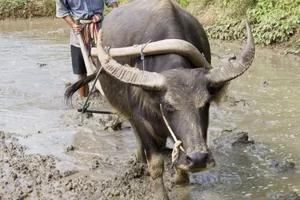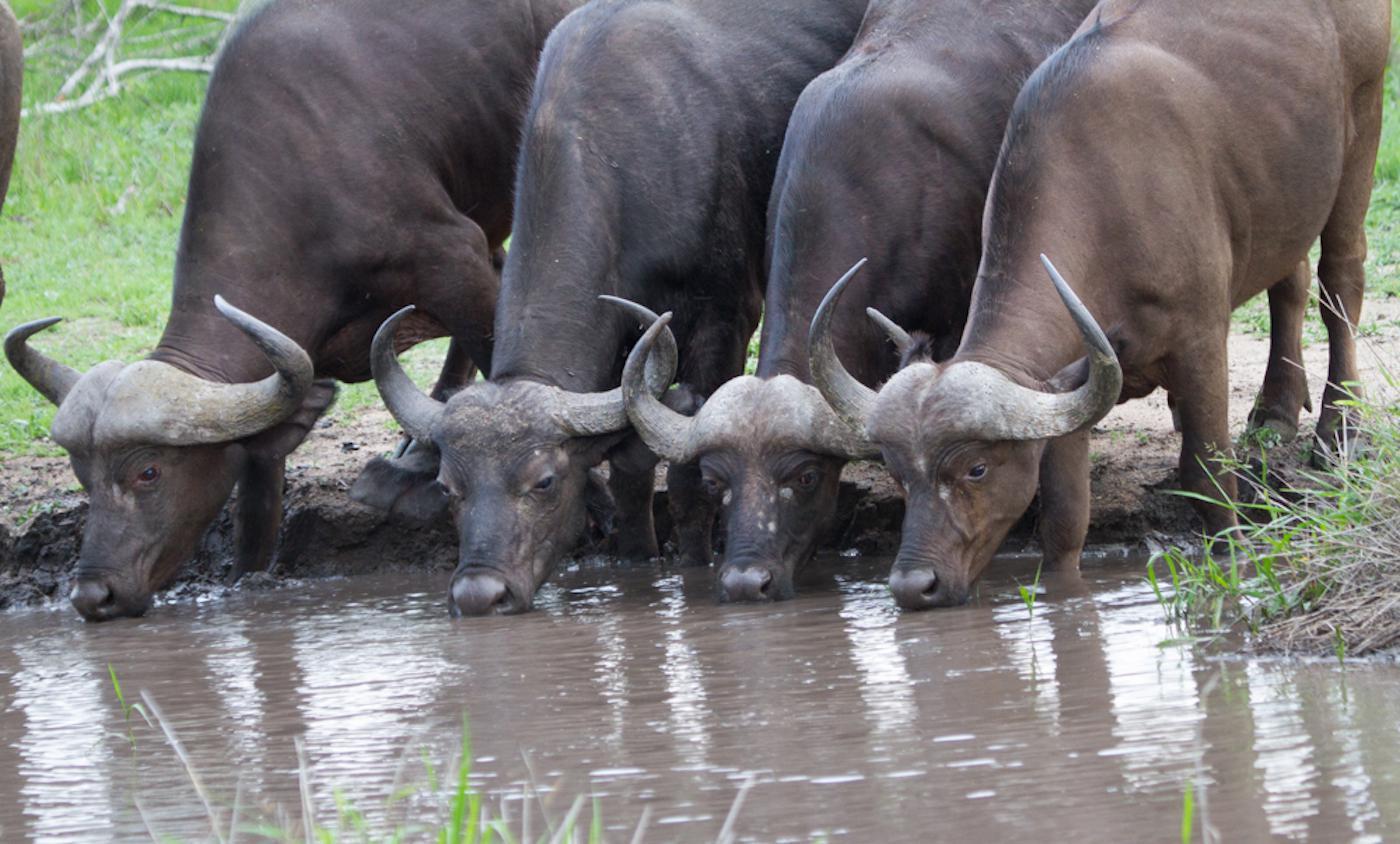The first image is the image on the left, the second image is the image on the right. Examine the images to the left and right. Is the description "One image shows at least four water buffalo." accurate? Answer yes or no. Yes. The first image is the image on the left, the second image is the image on the right. Considering the images on both sides, is "There is more than one animal in the image on the right" valid? Answer yes or no. Yes. 